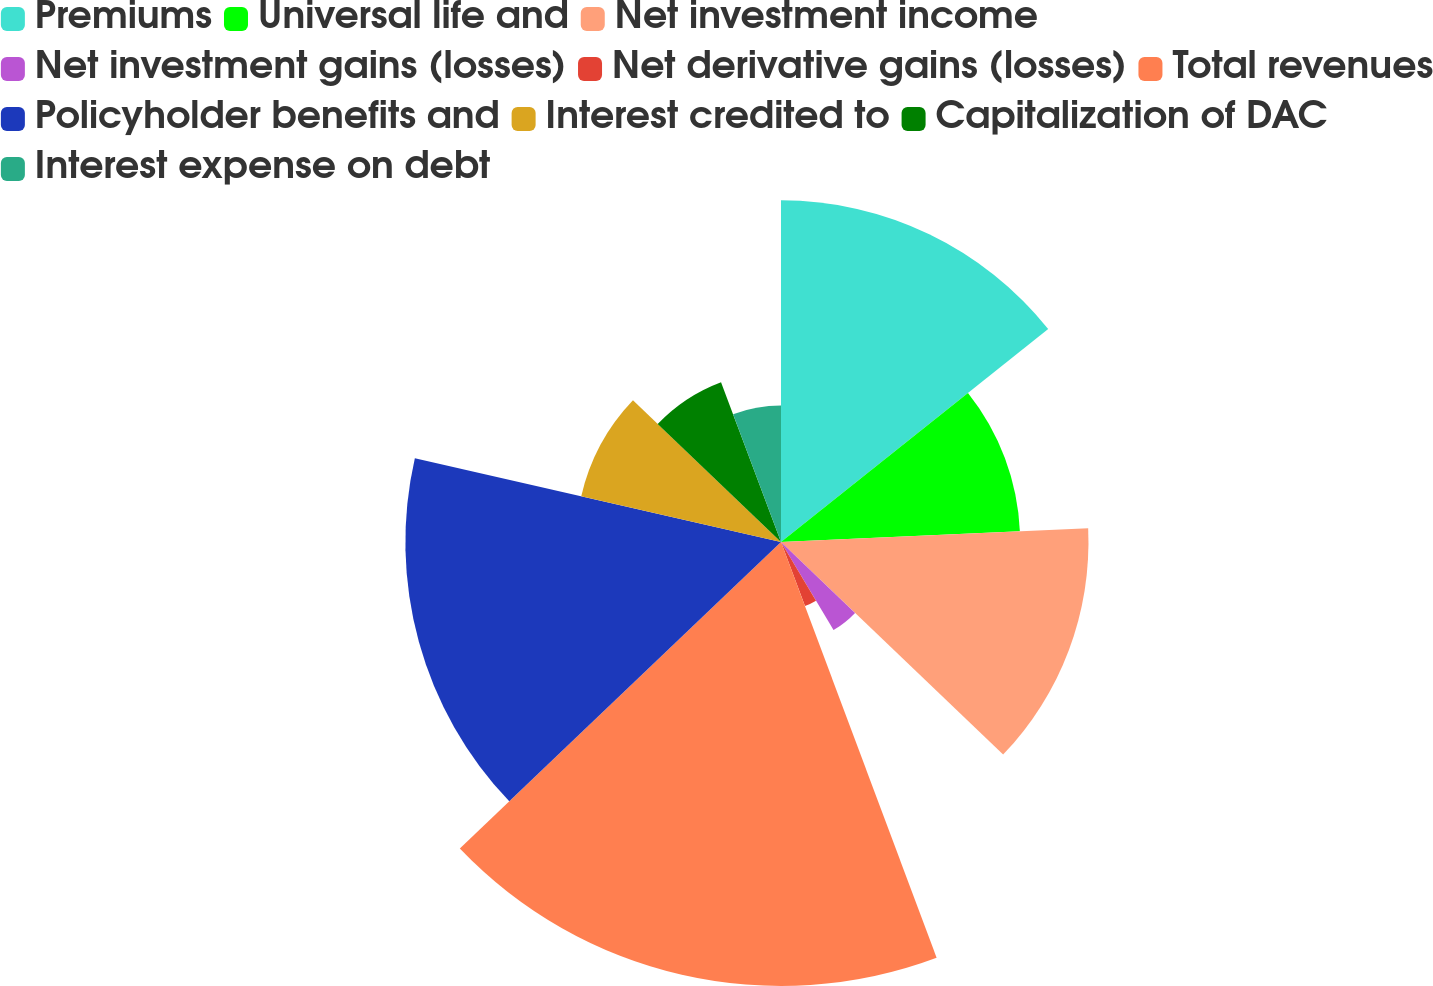<chart> <loc_0><loc_0><loc_500><loc_500><pie_chart><fcel>Premiums<fcel>Universal life and<fcel>Net investment income<fcel>Net investment gains (losses)<fcel>Net derivative gains (losses)<fcel>Total revenues<fcel>Policyholder benefits and<fcel>Interest credited to<fcel>Capitalization of DAC<fcel>Interest expense on debt<nl><fcel>14.29%<fcel>10.0%<fcel>12.86%<fcel>4.29%<fcel>2.86%<fcel>18.57%<fcel>15.71%<fcel>8.57%<fcel>7.14%<fcel>5.71%<nl></chart> 